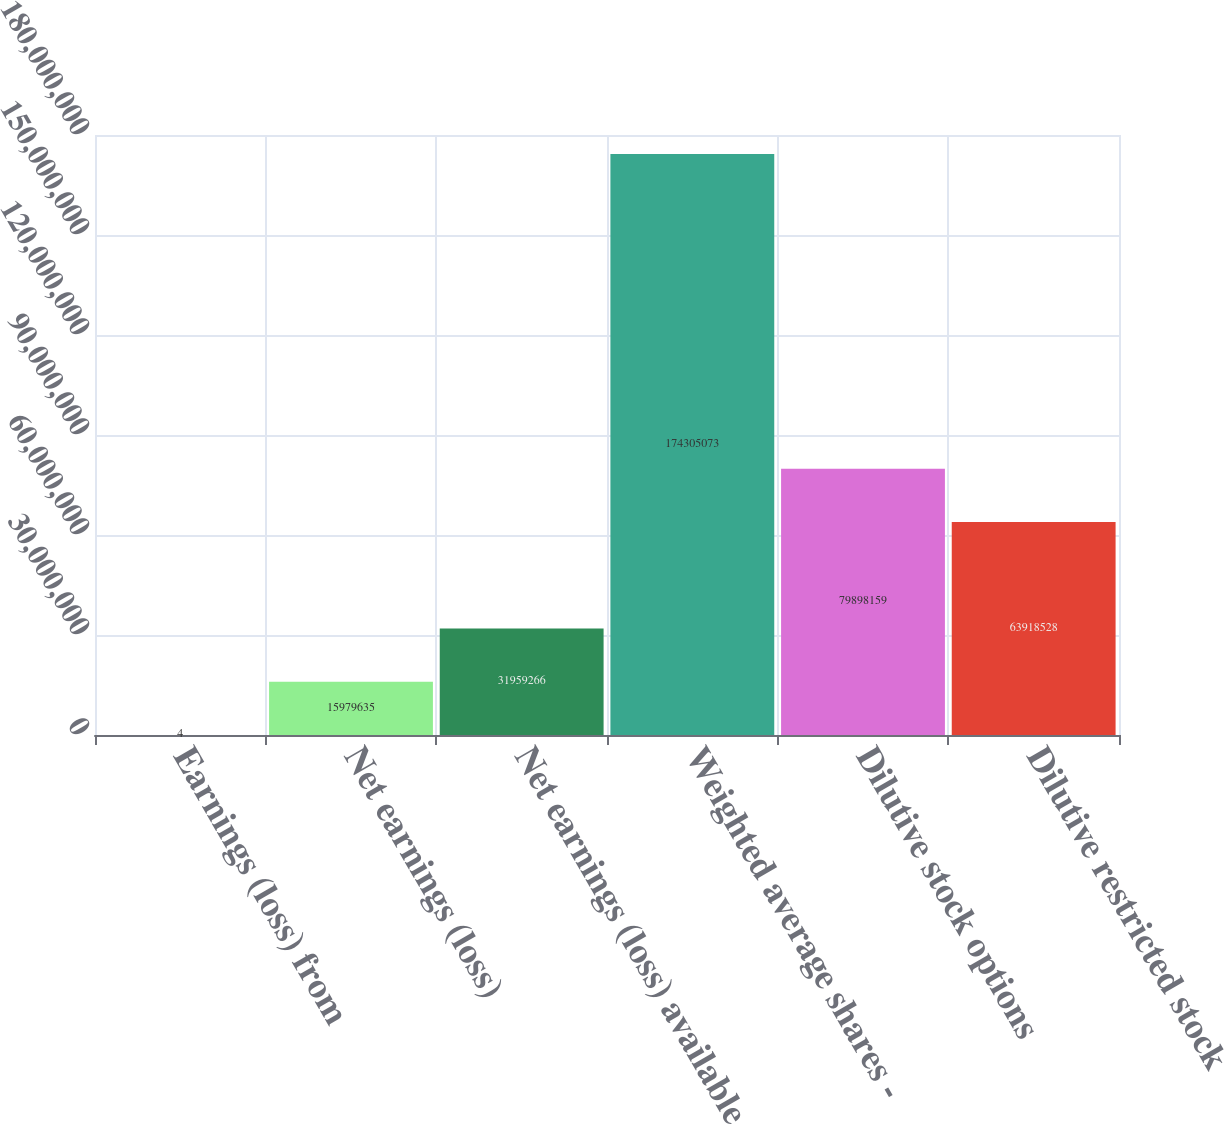Convert chart. <chart><loc_0><loc_0><loc_500><loc_500><bar_chart><fcel>Earnings (loss) from<fcel>Net earnings (loss)<fcel>Net earnings (loss) available<fcel>Weighted average shares -<fcel>Dilutive stock options<fcel>Dilutive restricted stock<nl><fcel>4<fcel>1.59796e+07<fcel>3.19593e+07<fcel>1.74305e+08<fcel>7.98982e+07<fcel>6.39185e+07<nl></chart> 